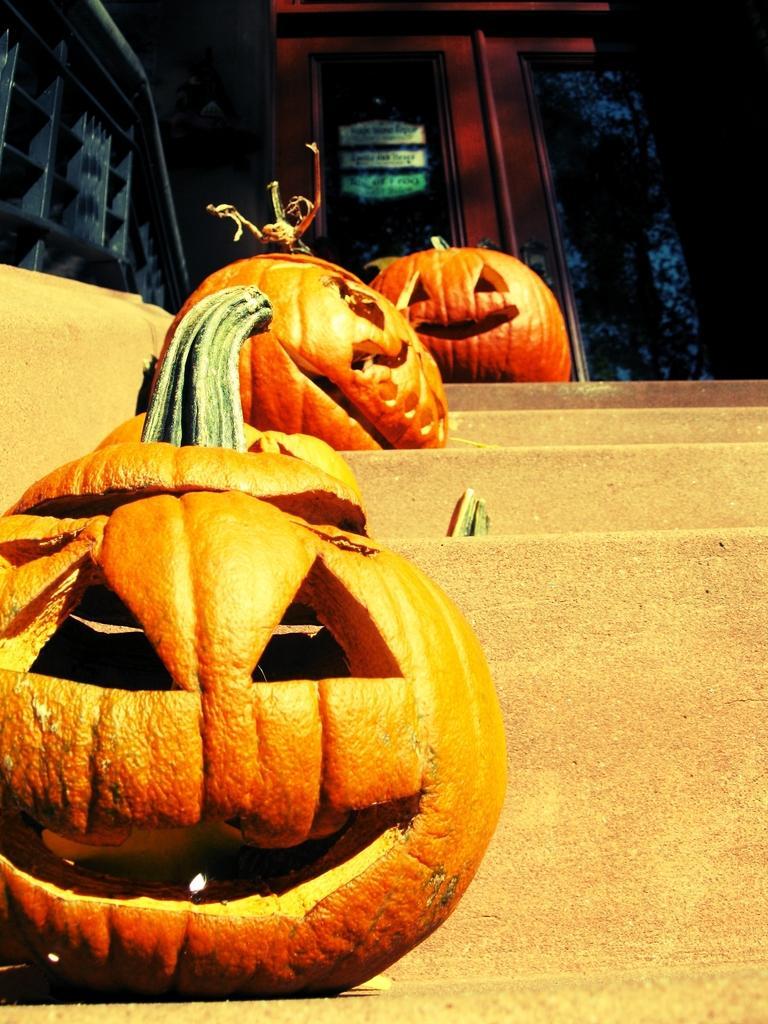In one or two sentences, can you explain what this image depicts? In this picture I can see there are few pumpkins placed on the stairs and there is a door in the backdrop. 